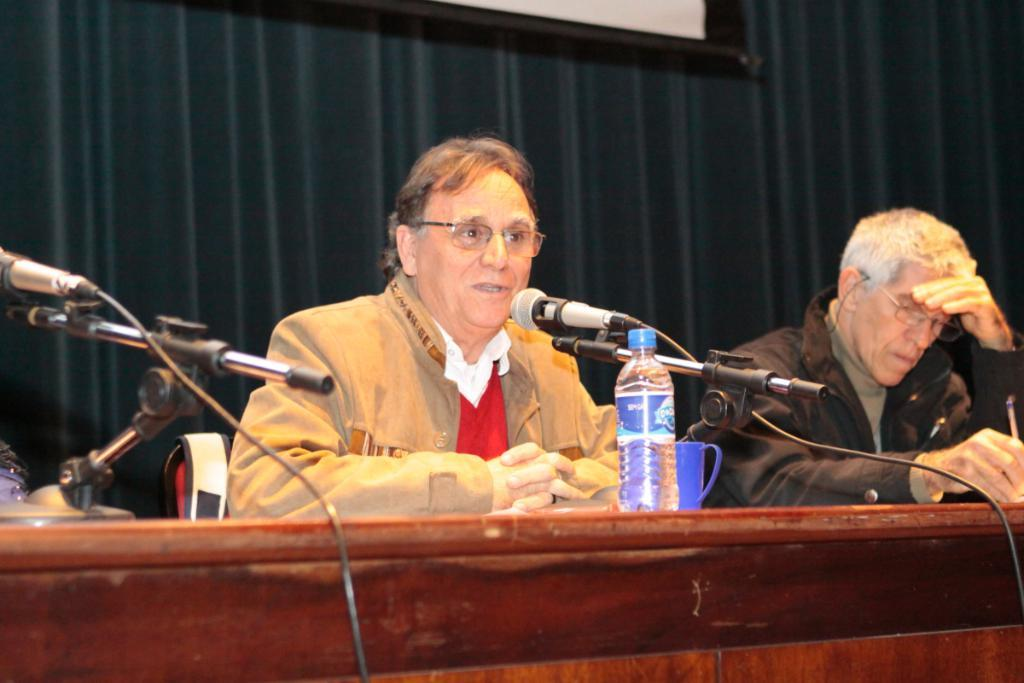How many men are in the image? There are two men in the image. What are the men doing in the image? The men are sitting in the image. What are the men wearing that is mentioned in the facts? The men are wearing glasses. What is in front of the men in the image? There is a platform in front of the men. What can be found on the platform? There are microphones with mic stands, a bottle, and a cup on the platform. What is visible in the background of the image? There is a curtain in the background. What type of hook can be seen hanging from the curtain in the image? There is no hook visible in the image, as it only mentions a curtain in the background. 